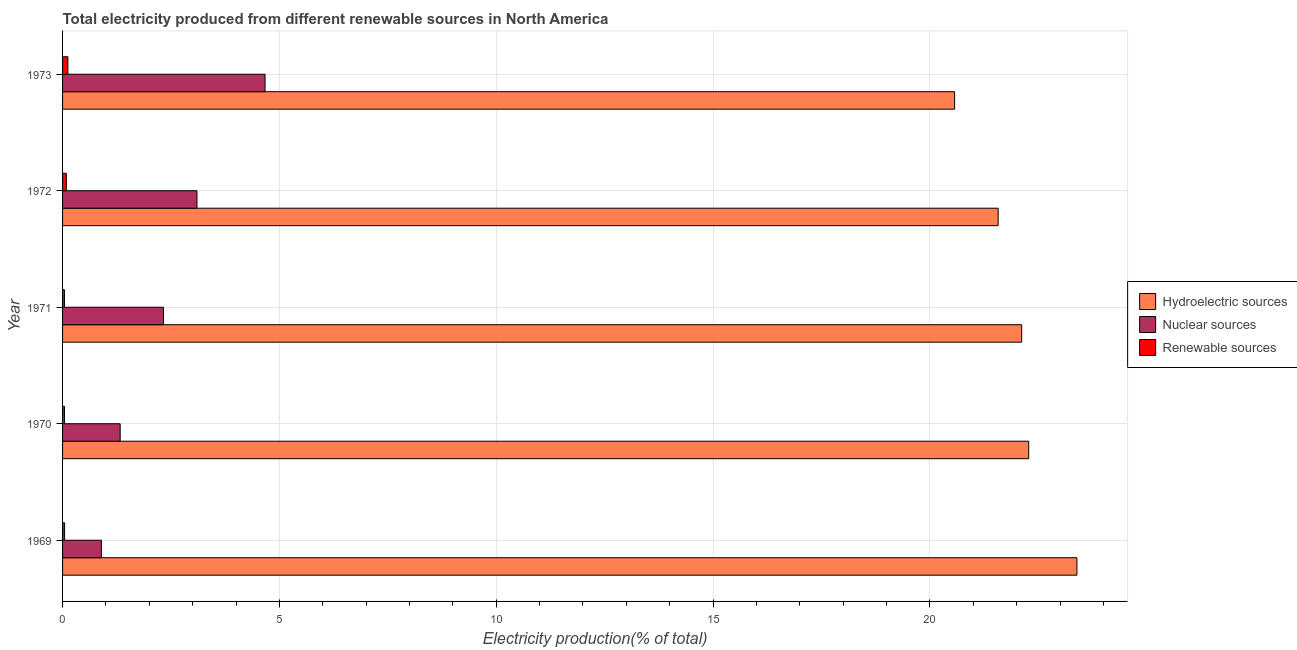How many different coloured bars are there?
Your answer should be very brief. 3. How many groups of bars are there?
Your response must be concise. 5. How many bars are there on the 1st tick from the top?
Your answer should be very brief. 3. How many bars are there on the 4th tick from the bottom?
Give a very brief answer. 3. In how many cases, is the number of bars for a given year not equal to the number of legend labels?
Your answer should be very brief. 0. What is the percentage of electricity produced by nuclear sources in 1973?
Your answer should be very brief. 4.67. Across all years, what is the maximum percentage of electricity produced by renewable sources?
Keep it short and to the point. 0.12. Across all years, what is the minimum percentage of electricity produced by hydroelectric sources?
Offer a very short reply. 20.57. In which year was the percentage of electricity produced by hydroelectric sources maximum?
Provide a short and direct response. 1969. In which year was the percentage of electricity produced by nuclear sources minimum?
Offer a terse response. 1969. What is the total percentage of electricity produced by hydroelectric sources in the graph?
Ensure brevity in your answer.  109.93. What is the difference between the percentage of electricity produced by nuclear sources in 1970 and that in 1971?
Your response must be concise. -1. What is the difference between the percentage of electricity produced by renewable sources in 1970 and the percentage of electricity produced by hydroelectric sources in 1972?
Offer a terse response. -21.53. What is the average percentage of electricity produced by renewable sources per year?
Make the answer very short. 0.07. In the year 1973, what is the difference between the percentage of electricity produced by renewable sources and percentage of electricity produced by hydroelectric sources?
Give a very brief answer. -20.45. In how many years, is the percentage of electricity produced by nuclear sources greater than 9 %?
Ensure brevity in your answer.  0. What is the ratio of the percentage of electricity produced by renewable sources in 1970 to that in 1972?
Your answer should be very brief. 0.51. Is the percentage of electricity produced by nuclear sources in 1970 less than that in 1972?
Make the answer very short. Yes. What is the difference between the highest and the second highest percentage of electricity produced by renewable sources?
Your response must be concise. 0.04. What is the difference between the highest and the lowest percentage of electricity produced by hydroelectric sources?
Make the answer very short. 2.82. Is the sum of the percentage of electricity produced by hydroelectric sources in 1970 and 1971 greater than the maximum percentage of electricity produced by renewable sources across all years?
Ensure brevity in your answer.  Yes. What does the 2nd bar from the top in 1970 represents?
Provide a short and direct response. Nuclear sources. What does the 1st bar from the bottom in 1969 represents?
Offer a terse response. Hydroelectric sources. Is it the case that in every year, the sum of the percentage of electricity produced by hydroelectric sources and percentage of electricity produced by nuclear sources is greater than the percentage of electricity produced by renewable sources?
Keep it short and to the point. Yes. How many bars are there?
Keep it short and to the point. 15. How many years are there in the graph?
Provide a short and direct response. 5. Are the values on the major ticks of X-axis written in scientific E-notation?
Keep it short and to the point. No. Does the graph contain grids?
Give a very brief answer. Yes. What is the title of the graph?
Ensure brevity in your answer.  Total electricity produced from different renewable sources in North America. What is the Electricity production(% of total) of Hydroelectric sources in 1969?
Your response must be concise. 23.39. What is the Electricity production(% of total) in Nuclear sources in 1969?
Provide a succinct answer. 0.9. What is the Electricity production(% of total) in Renewable sources in 1969?
Your answer should be compact. 0.05. What is the Electricity production(% of total) in Hydroelectric sources in 1970?
Give a very brief answer. 22.28. What is the Electricity production(% of total) of Nuclear sources in 1970?
Your answer should be very brief. 1.33. What is the Electricity production(% of total) in Renewable sources in 1970?
Your response must be concise. 0.04. What is the Electricity production(% of total) of Hydroelectric sources in 1971?
Make the answer very short. 22.12. What is the Electricity production(% of total) of Nuclear sources in 1971?
Provide a short and direct response. 2.33. What is the Electricity production(% of total) in Renewable sources in 1971?
Your answer should be very brief. 0.04. What is the Electricity production(% of total) of Hydroelectric sources in 1972?
Offer a very short reply. 21.57. What is the Electricity production(% of total) of Nuclear sources in 1972?
Provide a short and direct response. 3.1. What is the Electricity production(% of total) of Renewable sources in 1972?
Make the answer very short. 0.09. What is the Electricity production(% of total) in Hydroelectric sources in 1973?
Keep it short and to the point. 20.57. What is the Electricity production(% of total) in Nuclear sources in 1973?
Provide a succinct answer. 4.67. What is the Electricity production(% of total) of Renewable sources in 1973?
Make the answer very short. 0.12. Across all years, what is the maximum Electricity production(% of total) in Hydroelectric sources?
Offer a very short reply. 23.39. Across all years, what is the maximum Electricity production(% of total) of Nuclear sources?
Make the answer very short. 4.67. Across all years, what is the maximum Electricity production(% of total) in Renewable sources?
Keep it short and to the point. 0.12. Across all years, what is the minimum Electricity production(% of total) in Hydroelectric sources?
Keep it short and to the point. 20.57. Across all years, what is the minimum Electricity production(% of total) of Nuclear sources?
Your answer should be compact. 0.9. Across all years, what is the minimum Electricity production(% of total) of Renewable sources?
Offer a very short reply. 0.04. What is the total Electricity production(% of total) in Hydroelectric sources in the graph?
Your response must be concise. 109.93. What is the total Electricity production(% of total) in Nuclear sources in the graph?
Keep it short and to the point. 12.32. What is the total Electricity production(% of total) of Renewable sources in the graph?
Your answer should be very brief. 0.35. What is the difference between the Electricity production(% of total) of Hydroelectric sources in 1969 and that in 1970?
Ensure brevity in your answer.  1.11. What is the difference between the Electricity production(% of total) in Nuclear sources in 1969 and that in 1970?
Offer a terse response. -0.43. What is the difference between the Electricity production(% of total) in Renewable sources in 1969 and that in 1970?
Give a very brief answer. 0. What is the difference between the Electricity production(% of total) of Hydroelectric sources in 1969 and that in 1971?
Ensure brevity in your answer.  1.27. What is the difference between the Electricity production(% of total) of Nuclear sources in 1969 and that in 1971?
Your answer should be compact. -1.43. What is the difference between the Electricity production(% of total) of Renewable sources in 1969 and that in 1971?
Your response must be concise. 0. What is the difference between the Electricity production(% of total) of Hydroelectric sources in 1969 and that in 1972?
Offer a terse response. 1.82. What is the difference between the Electricity production(% of total) in Nuclear sources in 1969 and that in 1972?
Keep it short and to the point. -2.2. What is the difference between the Electricity production(% of total) of Renewable sources in 1969 and that in 1972?
Offer a terse response. -0.04. What is the difference between the Electricity production(% of total) in Hydroelectric sources in 1969 and that in 1973?
Provide a succinct answer. 2.82. What is the difference between the Electricity production(% of total) of Nuclear sources in 1969 and that in 1973?
Give a very brief answer. -3.77. What is the difference between the Electricity production(% of total) of Renewable sources in 1969 and that in 1973?
Provide a succinct answer. -0.08. What is the difference between the Electricity production(% of total) in Hydroelectric sources in 1970 and that in 1971?
Make the answer very short. 0.16. What is the difference between the Electricity production(% of total) of Nuclear sources in 1970 and that in 1971?
Keep it short and to the point. -1. What is the difference between the Electricity production(% of total) of Renewable sources in 1970 and that in 1971?
Keep it short and to the point. 0. What is the difference between the Electricity production(% of total) of Hydroelectric sources in 1970 and that in 1972?
Your answer should be compact. 0.7. What is the difference between the Electricity production(% of total) in Nuclear sources in 1970 and that in 1972?
Your answer should be very brief. -1.77. What is the difference between the Electricity production(% of total) of Renewable sources in 1970 and that in 1972?
Give a very brief answer. -0.04. What is the difference between the Electricity production(% of total) in Hydroelectric sources in 1970 and that in 1973?
Offer a terse response. 1.71. What is the difference between the Electricity production(% of total) of Nuclear sources in 1970 and that in 1973?
Offer a terse response. -3.34. What is the difference between the Electricity production(% of total) of Renewable sources in 1970 and that in 1973?
Your response must be concise. -0.08. What is the difference between the Electricity production(% of total) of Hydroelectric sources in 1971 and that in 1972?
Make the answer very short. 0.54. What is the difference between the Electricity production(% of total) of Nuclear sources in 1971 and that in 1972?
Offer a very short reply. -0.77. What is the difference between the Electricity production(% of total) of Renewable sources in 1971 and that in 1972?
Offer a terse response. -0.04. What is the difference between the Electricity production(% of total) of Hydroelectric sources in 1971 and that in 1973?
Give a very brief answer. 1.55. What is the difference between the Electricity production(% of total) in Nuclear sources in 1971 and that in 1973?
Your answer should be very brief. -2.34. What is the difference between the Electricity production(% of total) in Renewable sources in 1971 and that in 1973?
Your answer should be very brief. -0.08. What is the difference between the Electricity production(% of total) of Hydroelectric sources in 1972 and that in 1973?
Offer a terse response. 1. What is the difference between the Electricity production(% of total) of Nuclear sources in 1972 and that in 1973?
Your answer should be compact. -1.57. What is the difference between the Electricity production(% of total) of Renewable sources in 1972 and that in 1973?
Your answer should be very brief. -0.04. What is the difference between the Electricity production(% of total) of Hydroelectric sources in 1969 and the Electricity production(% of total) of Nuclear sources in 1970?
Your answer should be compact. 22.06. What is the difference between the Electricity production(% of total) of Hydroelectric sources in 1969 and the Electricity production(% of total) of Renewable sources in 1970?
Make the answer very short. 23.34. What is the difference between the Electricity production(% of total) of Nuclear sources in 1969 and the Electricity production(% of total) of Renewable sources in 1970?
Keep it short and to the point. 0.85. What is the difference between the Electricity production(% of total) in Hydroelectric sources in 1969 and the Electricity production(% of total) in Nuclear sources in 1971?
Provide a short and direct response. 21.06. What is the difference between the Electricity production(% of total) of Hydroelectric sources in 1969 and the Electricity production(% of total) of Renewable sources in 1971?
Ensure brevity in your answer.  23.35. What is the difference between the Electricity production(% of total) in Nuclear sources in 1969 and the Electricity production(% of total) in Renewable sources in 1971?
Keep it short and to the point. 0.85. What is the difference between the Electricity production(% of total) in Hydroelectric sources in 1969 and the Electricity production(% of total) in Nuclear sources in 1972?
Your answer should be compact. 20.29. What is the difference between the Electricity production(% of total) of Hydroelectric sources in 1969 and the Electricity production(% of total) of Renewable sources in 1972?
Your answer should be very brief. 23.3. What is the difference between the Electricity production(% of total) in Nuclear sources in 1969 and the Electricity production(% of total) in Renewable sources in 1972?
Your response must be concise. 0.81. What is the difference between the Electricity production(% of total) of Hydroelectric sources in 1969 and the Electricity production(% of total) of Nuclear sources in 1973?
Keep it short and to the point. 18.72. What is the difference between the Electricity production(% of total) in Hydroelectric sources in 1969 and the Electricity production(% of total) in Renewable sources in 1973?
Provide a short and direct response. 23.27. What is the difference between the Electricity production(% of total) in Nuclear sources in 1969 and the Electricity production(% of total) in Renewable sources in 1973?
Give a very brief answer. 0.77. What is the difference between the Electricity production(% of total) of Hydroelectric sources in 1970 and the Electricity production(% of total) of Nuclear sources in 1971?
Make the answer very short. 19.95. What is the difference between the Electricity production(% of total) of Hydroelectric sources in 1970 and the Electricity production(% of total) of Renewable sources in 1971?
Give a very brief answer. 22.23. What is the difference between the Electricity production(% of total) in Nuclear sources in 1970 and the Electricity production(% of total) in Renewable sources in 1971?
Ensure brevity in your answer.  1.28. What is the difference between the Electricity production(% of total) of Hydroelectric sources in 1970 and the Electricity production(% of total) of Nuclear sources in 1972?
Provide a short and direct response. 19.18. What is the difference between the Electricity production(% of total) in Hydroelectric sources in 1970 and the Electricity production(% of total) in Renewable sources in 1972?
Your answer should be compact. 22.19. What is the difference between the Electricity production(% of total) of Nuclear sources in 1970 and the Electricity production(% of total) of Renewable sources in 1972?
Offer a terse response. 1.24. What is the difference between the Electricity production(% of total) in Hydroelectric sources in 1970 and the Electricity production(% of total) in Nuclear sources in 1973?
Ensure brevity in your answer.  17.61. What is the difference between the Electricity production(% of total) of Hydroelectric sources in 1970 and the Electricity production(% of total) of Renewable sources in 1973?
Your answer should be compact. 22.16. What is the difference between the Electricity production(% of total) of Nuclear sources in 1970 and the Electricity production(% of total) of Renewable sources in 1973?
Offer a terse response. 1.21. What is the difference between the Electricity production(% of total) of Hydroelectric sources in 1971 and the Electricity production(% of total) of Nuclear sources in 1972?
Your answer should be compact. 19.02. What is the difference between the Electricity production(% of total) in Hydroelectric sources in 1971 and the Electricity production(% of total) in Renewable sources in 1972?
Give a very brief answer. 22.03. What is the difference between the Electricity production(% of total) of Nuclear sources in 1971 and the Electricity production(% of total) of Renewable sources in 1972?
Offer a terse response. 2.24. What is the difference between the Electricity production(% of total) in Hydroelectric sources in 1971 and the Electricity production(% of total) in Nuclear sources in 1973?
Make the answer very short. 17.45. What is the difference between the Electricity production(% of total) of Hydroelectric sources in 1971 and the Electricity production(% of total) of Renewable sources in 1973?
Your answer should be compact. 21.99. What is the difference between the Electricity production(% of total) of Nuclear sources in 1971 and the Electricity production(% of total) of Renewable sources in 1973?
Provide a succinct answer. 2.2. What is the difference between the Electricity production(% of total) in Hydroelectric sources in 1972 and the Electricity production(% of total) in Nuclear sources in 1973?
Give a very brief answer. 16.9. What is the difference between the Electricity production(% of total) of Hydroelectric sources in 1972 and the Electricity production(% of total) of Renewable sources in 1973?
Ensure brevity in your answer.  21.45. What is the difference between the Electricity production(% of total) of Nuclear sources in 1972 and the Electricity production(% of total) of Renewable sources in 1973?
Keep it short and to the point. 2.98. What is the average Electricity production(% of total) in Hydroelectric sources per year?
Provide a succinct answer. 21.99. What is the average Electricity production(% of total) in Nuclear sources per year?
Make the answer very short. 2.46. What is the average Electricity production(% of total) in Renewable sources per year?
Offer a very short reply. 0.07. In the year 1969, what is the difference between the Electricity production(% of total) in Hydroelectric sources and Electricity production(% of total) in Nuclear sources?
Your response must be concise. 22.49. In the year 1969, what is the difference between the Electricity production(% of total) in Hydroelectric sources and Electricity production(% of total) in Renewable sources?
Offer a very short reply. 23.34. In the year 1969, what is the difference between the Electricity production(% of total) of Nuclear sources and Electricity production(% of total) of Renewable sources?
Keep it short and to the point. 0.85. In the year 1970, what is the difference between the Electricity production(% of total) of Hydroelectric sources and Electricity production(% of total) of Nuclear sources?
Offer a very short reply. 20.95. In the year 1970, what is the difference between the Electricity production(% of total) of Hydroelectric sources and Electricity production(% of total) of Renewable sources?
Ensure brevity in your answer.  22.23. In the year 1970, what is the difference between the Electricity production(% of total) of Nuclear sources and Electricity production(% of total) of Renewable sources?
Offer a very short reply. 1.28. In the year 1971, what is the difference between the Electricity production(% of total) in Hydroelectric sources and Electricity production(% of total) in Nuclear sources?
Offer a terse response. 19.79. In the year 1971, what is the difference between the Electricity production(% of total) of Hydroelectric sources and Electricity production(% of total) of Renewable sources?
Provide a succinct answer. 22.07. In the year 1971, what is the difference between the Electricity production(% of total) of Nuclear sources and Electricity production(% of total) of Renewable sources?
Provide a succinct answer. 2.28. In the year 1972, what is the difference between the Electricity production(% of total) in Hydroelectric sources and Electricity production(% of total) in Nuclear sources?
Your answer should be compact. 18.47. In the year 1972, what is the difference between the Electricity production(% of total) in Hydroelectric sources and Electricity production(% of total) in Renewable sources?
Make the answer very short. 21.49. In the year 1972, what is the difference between the Electricity production(% of total) of Nuclear sources and Electricity production(% of total) of Renewable sources?
Ensure brevity in your answer.  3.01. In the year 1973, what is the difference between the Electricity production(% of total) in Hydroelectric sources and Electricity production(% of total) in Nuclear sources?
Your answer should be very brief. 15.9. In the year 1973, what is the difference between the Electricity production(% of total) in Hydroelectric sources and Electricity production(% of total) in Renewable sources?
Ensure brevity in your answer.  20.45. In the year 1973, what is the difference between the Electricity production(% of total) in Nuclear sources and Electricity production(% of total) in Renewable sources?
Provide a short and direct response. 4.55. What is the ratio of the Electricity production(% of total) in Hydroelectric sources in 1969 to that in 1970?
Your response must be concise. 1.05. What is the ratio of the Electricity production(% of total) in Nuclear sources in 1969 to that in 1970?
Make the answer very short. 0.67. What is the ratio of the Electricity production(% of total) of Renewable sources in 1969 to that in 1970?
Your answer should be compact. 1.04. What is the ratio of the Electricity production(% of total) in Hydroelectric sources in 1969 to that in 1971?
Keep it short and to the point. 1.06. What is the ratio of the Electricity production(% of total) of Nuclear sources in 1969 to that in 1971?
Your answer should be very brief. 0.38. What is the ratio of the Electricity production(% of total) in Renewable sources in 1969 to that in 1971?
Your response must be concise. 1.06. What is the ratio of the Electricity production(% of total) in Hydroelectric sources in 1969 to that in 1972?
Give a very brief answer. 1.08. What is the ratio of the Electricity production(% of total) in Nuclear sources in 1969 to that in 1972?
Your answer should be compact. 0.29. What is the ratio of the Electricity production(% of total) in Renewable sources in 1969 to that in 1972?
Give a very brief answer. 0.53. What is the ratio of the Electricity production(% of total) of Hydroelectric sources in 1969 to that in 1973?
Give a very brief answer. 1.14. What is the ratio of the Electricity production(% of total) of Nuclear sources in 1969 to that in 1973?
Provide a short and direct response. 0.19. What is the ratio of the Electricity production(% of total) of Renewable sources in 1969 to that in 1973?
Give a very brief answer. 0.38. What is the ratio of the Electricity production(% of total) in Hydroelectric sources in 1970 to that in 1971?
Offer a very short reply. 1.01. What is the ratio of the Electricity production(% of total) of Nuclear sources in 1970 to that in 1971?
Make the answer very short. 0.57. What is the ratio of the Electricity production(% of total) of Renewable sources in 1970 to that in 1971?
Make the answer very short. 1.02. What is the ratio of the Electricity production(% of total) in Hydroelectric sources in 1970 to that in 1972?
Provide a short and direct response. 1.03. What is the ratio of the Electricity production(% of total) of Nuclear sources in 1970 to that in 1972?
Your answer should be compact. 0.43. What is the ratio of the Electricity production(% of total) in Renewable sources in 1970 to that in 1972?
Provide a succinct answer. 0.51. What is the ratio of the Electricity production(% of total) of Hydroelectric sources in 1970 to that in 1973?
Make the answer very short. 1.08. What is the ratio of the Electricity production(% of total) of Nuclear sources in 1970 to that in 1973?
Provide a succinct answer. 0.28. What is the ratio of the Electricity production(% of total) of Renewable sources in 1970 to that in 1973?
Keep it short and to the point. 0.36. What is the ratio of the Electricity production(% of total) in Hydroelectric sources in 1971 to that in 1972?
Provide a succinct answer. 1.03. What is the ratio of the Electricity production(% of total) in Nuclear sources in 1971 to that in 1972?
Provide a short and direct response. 0.75. What is the ratio of the Electricity production(% of total) of Renewable sources in 1971 to that in 1972?
Ensure brevity in your answer.  0.5. What is the ratio of the Electricity production(% of total) of Hydroelectric sources in 1971 to that in 1973?
Offer a very short reply. 1.08. What is the ratio of the Electricity production(% of total) in Nuclear sources in 1971 to that in 1973?
Your answer should be very brief. 0.5. What is the ratio of the Electricity production(% of total) of Renewable sources in 1971 to that in 1973?
Ensure brevity in your answer.  0.36. What is the ratio of the Electricity production(% of total) of Hydroelectric sources in 1972 to that in 1973?
Keep it short and to the point. 1.05. What is the ratio of the Electricity production(% of total) of Nuclear sources in 1972 to that in 1973?
Give a very brief answer. 0.66. What is the ratio of the Electricity production(% of total) of Renewable sources in 1972 to that in 1973?
Offer a very short reply. 0.71. What is the difference between the highest and the second highest Electricity production(% of total) in Hydroelectric sources?
Give a very brief answer. 1.11. What is the difference between the highest and the second highest Electricity production(% of total) of Nuclear sources?
Your response must be concise. 1.57. What is the difference between the highest and the second highest Electricity production(% of total) of Renewable sources?
Your answer should be very brief. 0.04. What is the difference between the highest and the lowest Electricity production(% of total) in Hydroelectric sources?
Give a very brief answer. 2.82. What is the difference between the highest and the lowest Electricity production(% of total) of Nuclear sources?
Ensure brevity in your answer.  3.77. What is the difference between the highest and the lowest Electricity production(% of total) in Renewable sources?
Provide a short and direct response. 0.08. 